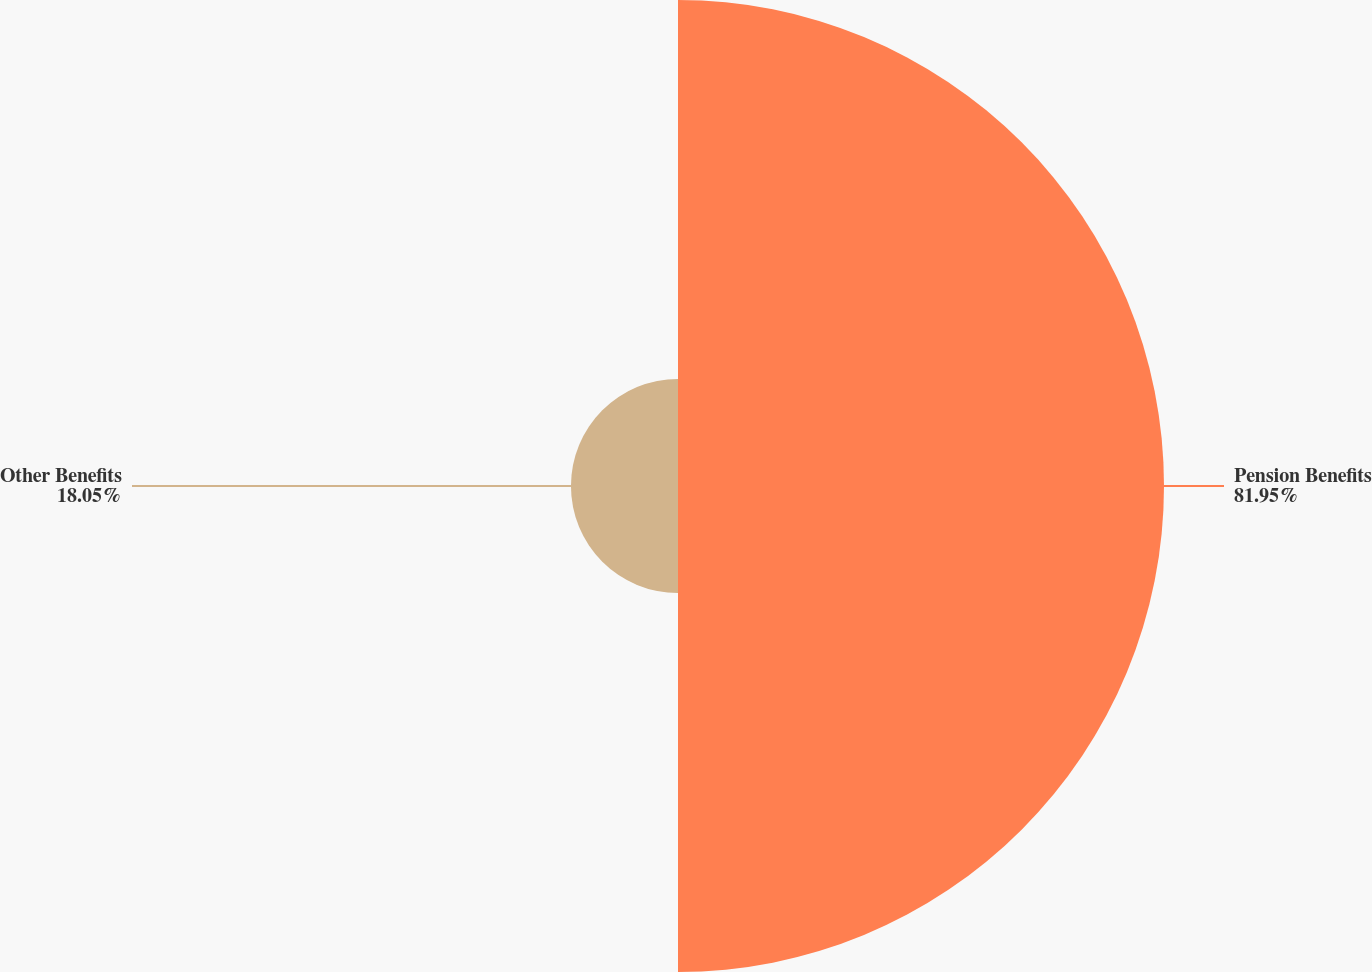<chart> <loc_0><loc_0><loc_500><loc_500><pie_chart><fcel>Pension Benefits<fcel>Other Benefits<nl><fcel>81.95%<fcel>18.05%<nl></chart> 